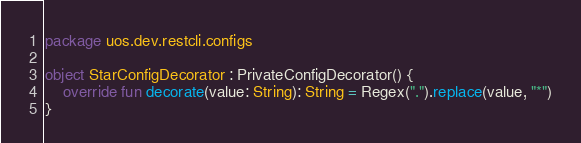Convert code to text. <code><loc_0><loc_0><loc_500><loc_500><_Kotlin_>package uos.dev.restcli.configs

object StarConfigDecorator : PrivateConfigDecorator() {
    override fun decorate(value: String): String = Regex(".").replace(value, "*")
}
</code> 